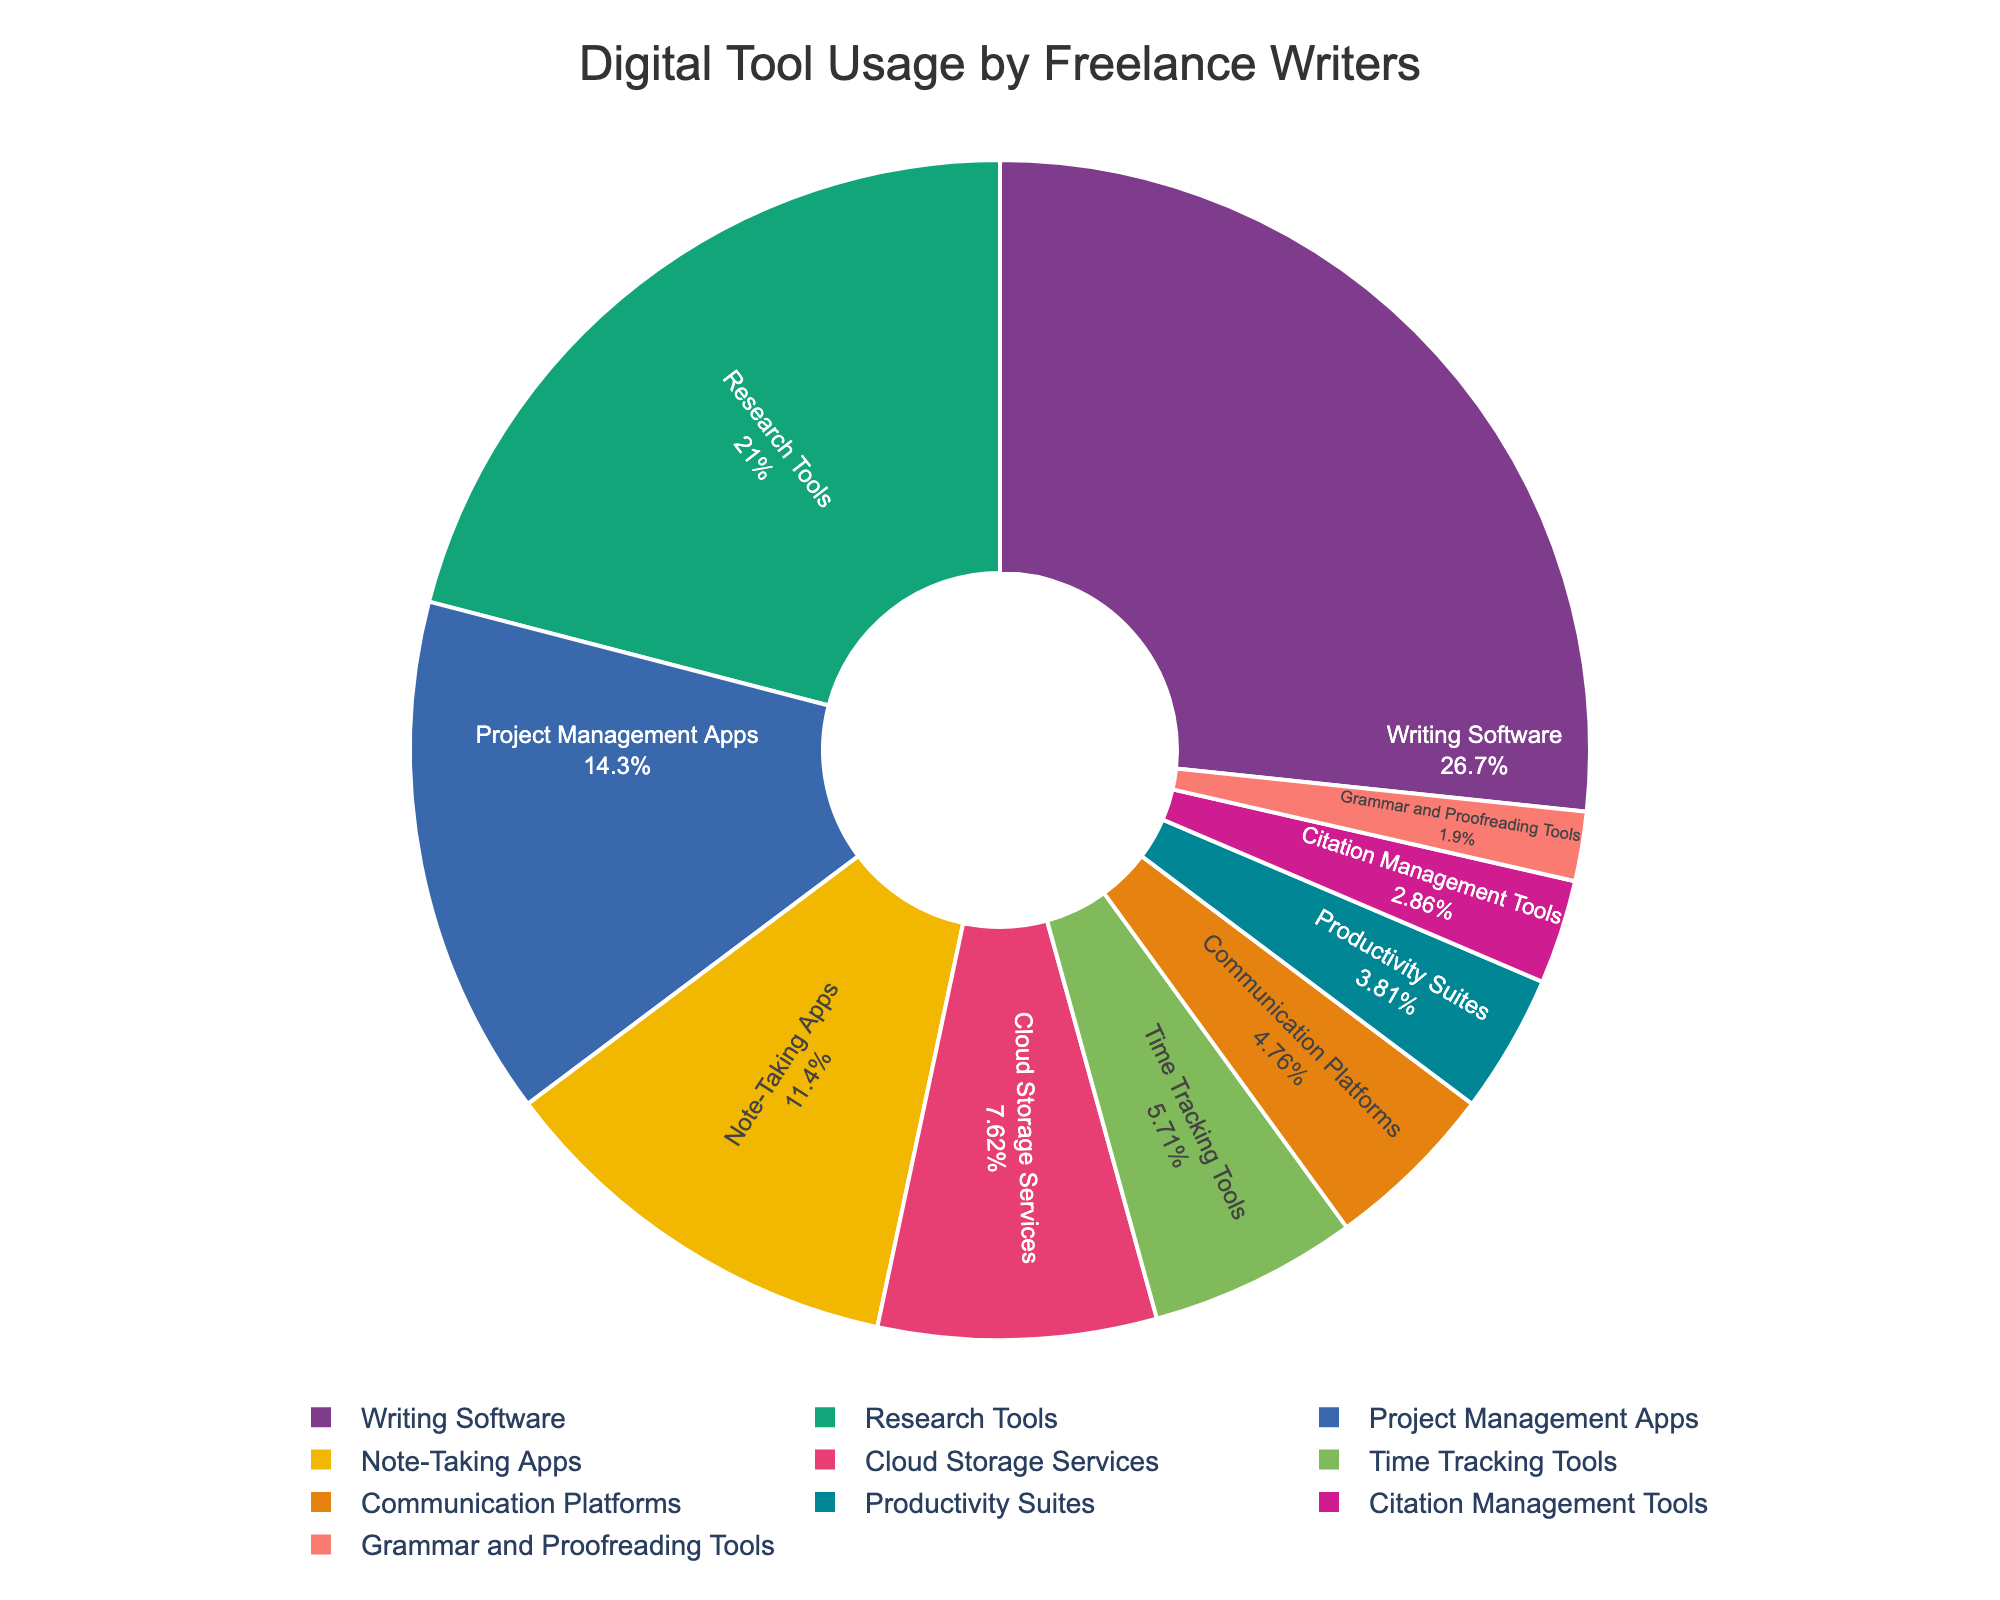What's the most utilized digital tool type by freelance writers? The tool type with the largest slice in the pie chart represents the most utilized tool by freelance writers. From the chart, Writing Software has the largest slice.
Answer: Writing Software What's the combined usage percentage of Project Management Apps and Time Tracking Tools? To find the combined usage percentage, add the usage percentages of the two tool types: 15% (Project Management Apps) + 6% (Time Tracking Tools) = 21%.
Answer: 21% Which tool type is used more: Note-Taking Apps or Cloud Storage Services? By comparing the sizes of the slices representing Note-Taking Apps (12%) and Cloud Storage Services (8%), Note-Taking Apps have a higher usage percentage.
Answer: Note-Taking Apps What is the total percentage usage for all tools that are used by less than 10% of freelance writers? Sum the usage percentages of the tool types with less than 10% usage: Cloud Storage Services (8%) + Time Tracking Tools (6%) + Communication Platforms (5%) + Productivity Suites (4%) + Citation Management Tools (3%) + Grammar and Proofreading Tools (2%) = 28%.
Answer: 28% How much higher is the usage percentage of Writing Software compared to Research Tools? Subtract the usage percentage of Research Tools (22%) from Writing Software (28%): 28% - 22% = 6%.
Answer: 6% What are the visual characteristics of the most-used tool type in the chart? The most used tool type, Writing Software, has the largest slice in the pie chart. It is positioned prominently, often at the top, and is labeled clearly with its usage percentage and name inside its section. It uses a color from the custom palette, likely a bold color to designate prominence.
Answer: Largest slice, prominent position, clear label Arrange the tool types in descending order of their usage percentages. Look at the sizes of the slices and their corresponding labels, then order from largest to smallest usage percentage: Writing Software (28%), Research Tools (22%), Project Management Apps (15%), Note-Taking Apps (12%), Cloud Storage Services (8%), Time Tracking Tools (6%), Communication Platforms (5%), Productivity Suites (4%), Citation Management Tools (3%), Grammar and Proofreading Tools (2%).
Answer: Writing Software, Research Tools, Project Management Apps, Note-Taking Apps, Cloud Storage Services, Time Tracking Tools, Communication Platforms, Productivity Suites, Citation Management Tools, Grammar and Proofreading Tools Which tool type occupies the smallest portion of the pie chart? Identify the tool type with the smallest slice in the pie chart. Here, Grammar and Proofreading Tools have the smallest slice with 2%.
Answer: Grammar and Proofreading Tools 